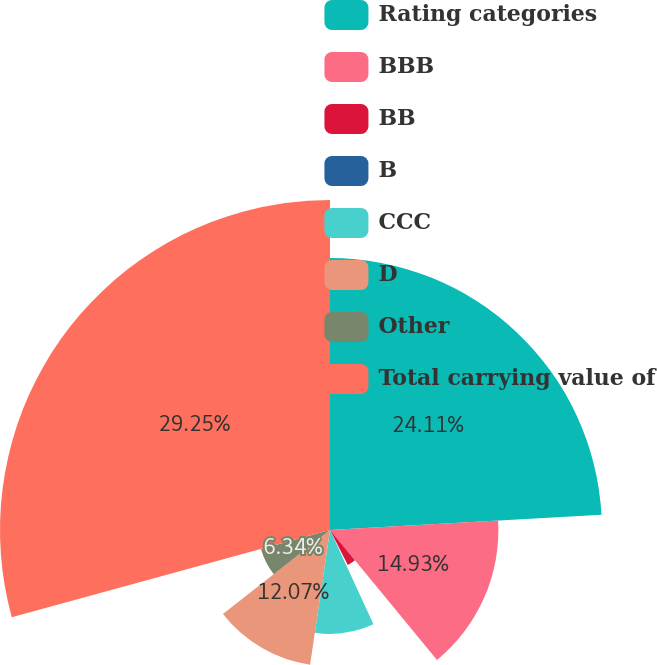Convert chart. <chart><loc_0><loc_0><loc_500><loc_500><pie_chart><fcel>Rating categories<fcel>BBB<fcel>BB<fcel>B<fcel>CCC<fcel>D<fcel>Other<fcel>Total carrying value of<nl><fcel>24.11%<fcel>14.93%<fcel>3.48%<fcel>0.61%<fcel>9.21%<fcel>12.07%<fcel>6.34%<fcel>29.26%<nl></chart> 